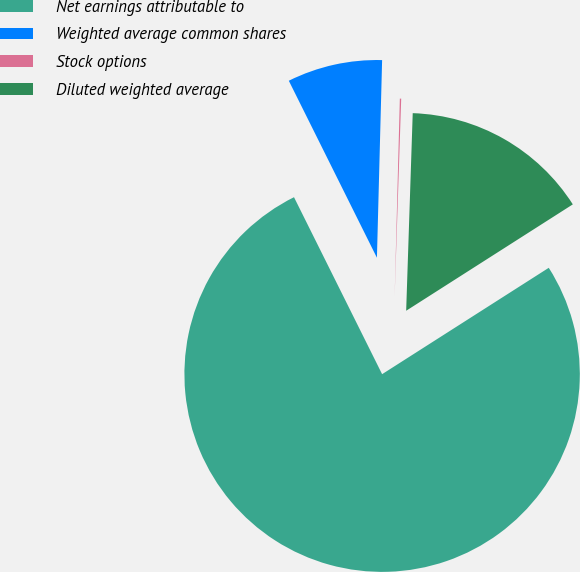<chart> <loc_0><loc_0><loc_500><loc_500><pie_chart><fcel>Net earnings attributable to<fcel>Weighted average common shares<fcel>Stock options<fcel>Diluted weighted average<nl><fcel>76.69%<fcel>7.77%<fcel>0.11%<fcel>15.43%<nl></chart> 